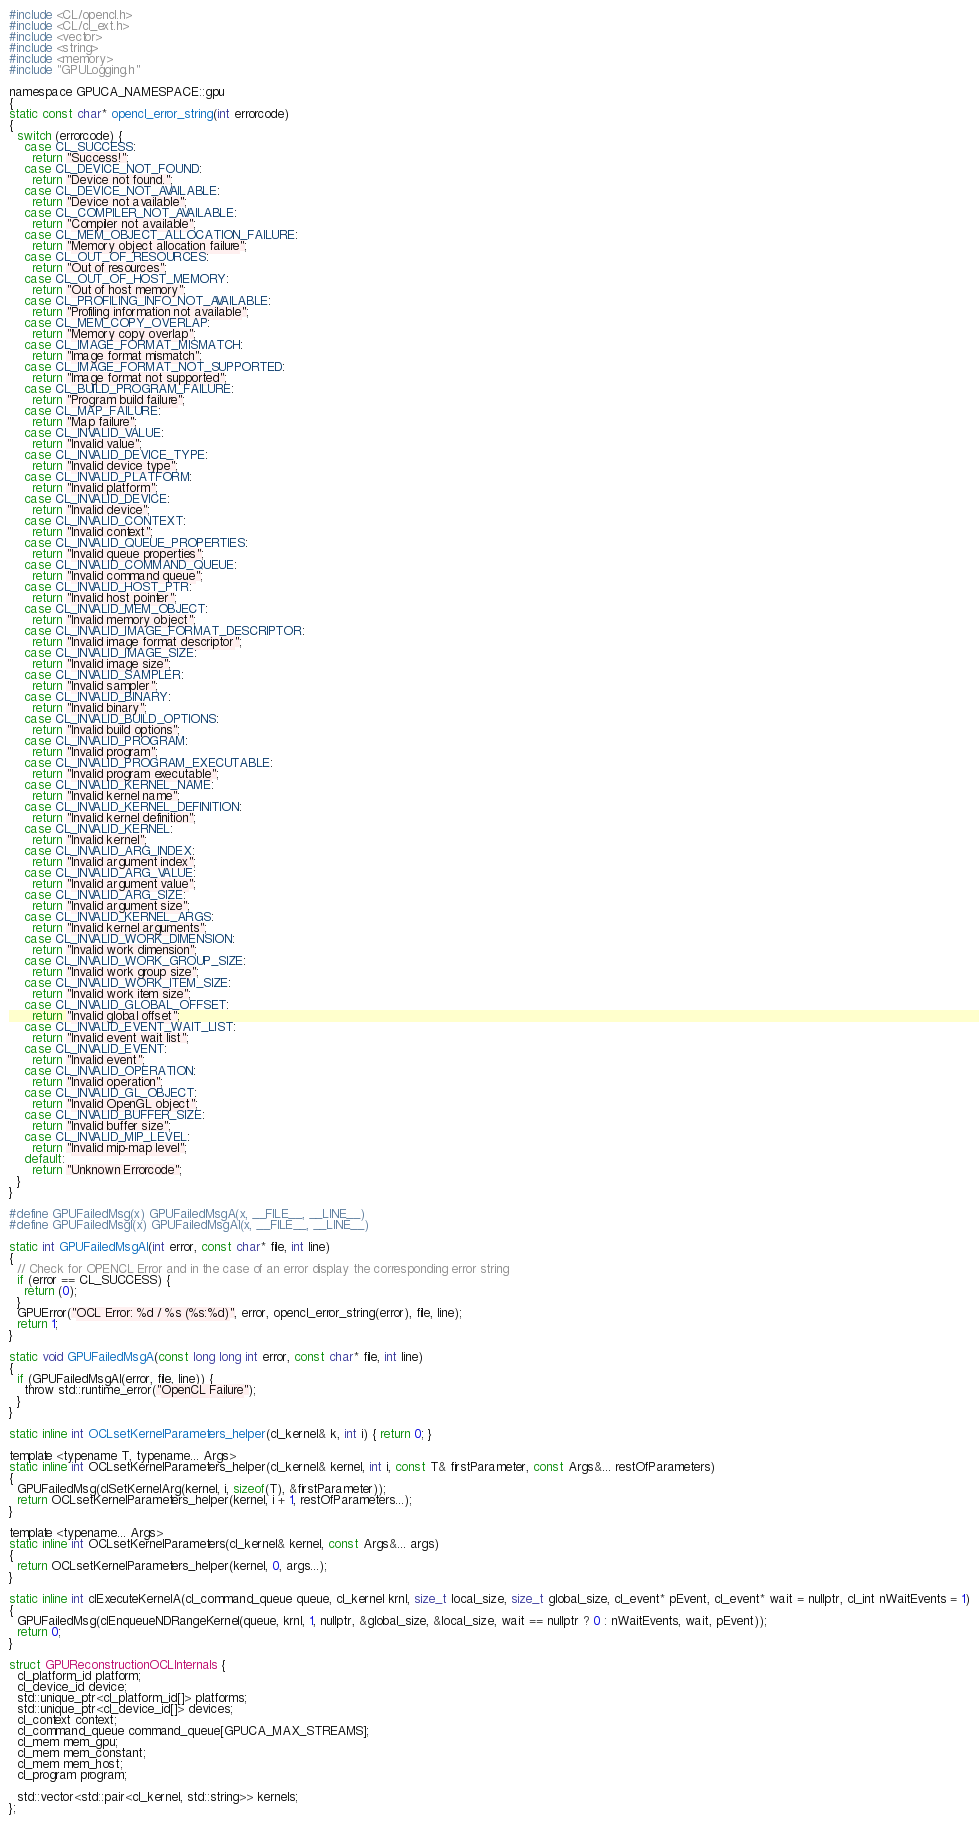<code> <loc_0><loc_0><loc_500><loc_500><_C_>#include <CL/opencl.h>
#include <CL/cl_ext.h>
#include <vector>
#include <string>
#include <memory>
#include "GPULogging.h"

namespace GPUCA_NAMESPACE::gpu
{
static const char* opencl_error_string(int errorcode)
{
  switch (errorcode) {
    case CL_SUCCESS:
      return "Success!";
    case CL_DEVICE_NOT_FOUND:
      return "Device not found.";
    case CL_DEVICE_NOT_AVAILABLE:
      return "Device not available";
    case CL_COMPILER_NOT_AVAILABLE:
      return "Compiler not available";
    case CL_MEM_OBJECT_ALLOCATION_FAILURE:
      return "Memory object allocation failure";
    case CL_OUT_OF_RESOURCES:
      return "Out of resources";
    case CL_OUT_OF_HOST_MEMORY:
      return "Out of host memory";
    case CL_PROFILING_INFO_NOT_AVAILABLE:
      return "Profiling information not available";
    case CL_MEM_COPY_OVERLAP:
      return "Memory copy overlap";
    case CL_IMAGE_FORMAT_MISMATCH:
      return "Image format mismatch";
    case CL_IMAGE_FORMAT_NOT_SUPPORTED:
      return "Image format not supported";
    case CL_BUILD_PROGRAM_FAILURE:
      return "Program build failure";
    case CL_MAP_FAILURE:
      return "Map failure";
    case CL_INVALID_VALUE:
      return "Invalid value";
    case CL_INVALID_DEVICE_TYPE:
      return "Invalid device type";
    case CL_INVALID_PLATFORM:
      return "Invalid platform";
    case CL_INVALID_DEVICE:
      return "Invalid device";
    case CL_INVALID_CONTEXT:
      return "Invalid context";
    case CL_INVALID_QUEUE_PROPERTIES:
      return "Invalid queue properties";
    case CL_INVALID_COMMAND_QUEUE:
      return "Invalid command queue";
    case CL_INVALID_HOST_PTR:
      return "Invalid host pointer";
    case CL_INVALID_MEM_OBJECT:
      return "Invalid memory object";
    case CL_INVALID_IMAGE_FORMAT_DESCRIPTOR:
      return "Invalid image format descriptor";
    case CL_INVALID_IMAGE_SIZE:
      return "Invalid image size";
    case CL_INVALID_SAMPLER:
      return "Invalid sampler";
    case CL_INVALID_BINARY:
      return "Invalid binary";
    case CL_INVALID_BUILD_OPTIONS:
      return "Invalid build options";
    case CL_INVALID_PROGRAM:
      return "Invalid program";
    case CL_INVALID_PROGRAM_EXECUTABLE:
      return "Invalid program executable";
    case CL_INVALID_KERNEL_NAME:
      return "Invalid kernel name";
    case CL_INVALID_KERNEL_DEFINITION:
      return "Invalid kernel definition";
    case CL_INVALID_KERNEL:
      return "Invalid kernel";
    case CL_INVALID_ARG_INDEX:
      return "Invalid argument index";
    case CL_INVALID_ARG_VALUE:
      return "Invalid argument value";
    case CL_INVALID_ARG_SIZE:
      return "Invalid argument size";
    case CL_INVALID_KERNEL_ARGS:
      return "Invalid kernel arguments";
    case CL_INVALID_WORK_DIMENSION:
      return "Invalid work dimension";
    case CL_INVALID_WORK_GROUP_SIZE:
      return "Invalid work group size";
    case CL_INVALID_WORK_ITEM_SIZE:
      return "Invalid work item size";
    case CL_INVALID_GLOBAL_OFFSET:
      return "Invalid global offset";
    case CL_INVALID_EVENT_WAIT_LIST:
      return "Invalid event wait list";
    case CL_INVALID_EVENT:
      return "Invalid event";
    case CL_INVALID_OPERATION:
      return "Invalid operation";
    case CL_INVALID_GL_OBJECT:
      return "Invalid OpenGL object";
    case CL_INVALID_BUFFER_SIZE:
      return "Invalid buffer size";
    case CL_INVALID_MIP_LEVEL:
      return "Invalid mip-map level";
    default:
      return "Unknown Errorcode";
  }
}

#define GPUFailedMsg(x) GPUFailedMsgA(x, __FILE__, __LINE__)
#define GPUFailedMsgI(x) GPUFailedMsgAI(x, __FILE__, __LINE__)

static int GPUFailedMsgAI(int error, const char* file, int line)
{
  // Check for OPENCL Error and in the case of an error display the corresponding error string
  if (error == CL_SUCCESS) {
    return (0);
  }
  GPUError("OCL Error: %d / %s (%s:%d)", error, opencl_error_string(error), file, line);
  return 1;
}

static void GPUFailedMsgA(const long long int error, const char* file, int line)
{
  if (GPUFailedMsgAI(error, file, line)) {
    throw std::runtime_error("OpenCL Failure");
  }
}

static inline int OCLsetKernelParameters_helper(cl_kernel& k, int i) { return 0; }

template <typename T, typename... Args>
static inline int OCLsetKernelParameters_helper(cl_kernel& kernel, int i, const T& firstParameter, const Args&... restOfParameters)
{
  GPUFailedMsg(clSetKernelArg(kernel, i, sizeof(T), &firstParameter));
  return OCLsetKernelParameters_helper(kernel, i + 1, restOfParameters...);
}

template <typename... Args>
static inline int OCLsetKernelParameters(cl_kernel& kernel, const Args&... args)
{
  return OCLsetKernelParameters_helper(kernel, 0, args...);
}

static inline int clExecuteKernelA(cl_command_queue queue, cl_kernel krnl, size_t local_size, size_t global_size, cl_event* pEvent, cl_event* wait = nullptr, cl_int nWaitEvents = 1)
{
  GPUFailedMsg(clEnqueueNDRangeKernel(queue, krnl, 1, nullptr, &global_size, &local_size, wait == nullptr ? 0 : nWaitEvents, wait, pEvent));
  return 0;
}

struct GPUReconstructionOCLInternals {
  cl_platform_id platform;
  cl_device_id device;
  std::unique_ptr<cl_platform_id[]> platforms;
  std::unique_ptr<cl_device_id[]> devices;
  cl_context context;
  cl_command_queue command_queue[GPUCA_MAX_STREAMS];
  cl_mem mem_gpu;
  cl_mem mem_constant;
  cl_mem mem_host;
  cl_program program;

  std::vector<std::pair<cl_kernel, std::string>> kernels;
};
</code> 